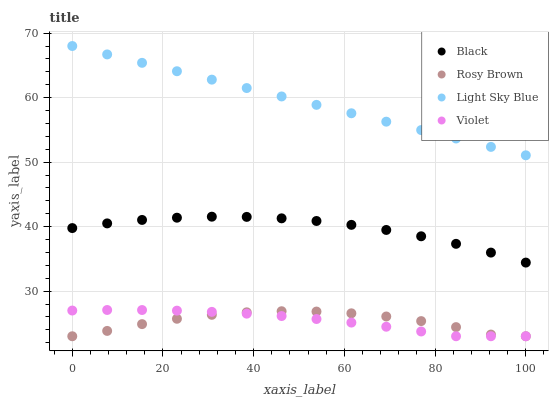Does Rosy Brown have the minimum area under the curve?
Answer yes or no. Yes. Does Light Sky Blue have the maximum area under the curve?
Answer yes or no. Yes. Does Black have the minimum area under the curve?
Answer yes or no. No. Does Black have the maximum area under the curve?
Answer yes or no. No. Is Light Sky Blue the smoothest?
Answer yes or no. Yes. Is Rosy Brown the roughest?
Answer yes or no. Yes. Is Black the smoothest?
Answer yes or no. No. Is Black the roughest?
Answer yes or no. No. Does Rosy Brown have the lowest value?
Answer yes or no. Yes. Does Black have the lowest value?
Answer yes or no. No. Does Light Sky Blue have the highest value?
Answer yes or no. Yes. Does Black have the highest value?
Answer yes or no. No. Is Violet less than Black?
Answer yes or no. Yes. Is Light Sky Blue greater than Violet?
Answer yes or no. Yes. Does Violet intersect Rosy Brown?
Answer yes or no. Yes. Is Violet less than Rosy Brown?
Answer yes or no. No. Is Violet greater than Rosy Brown?
Answer yes or no. No. Does Violet intersect Black?
Answer yes or no. No. 